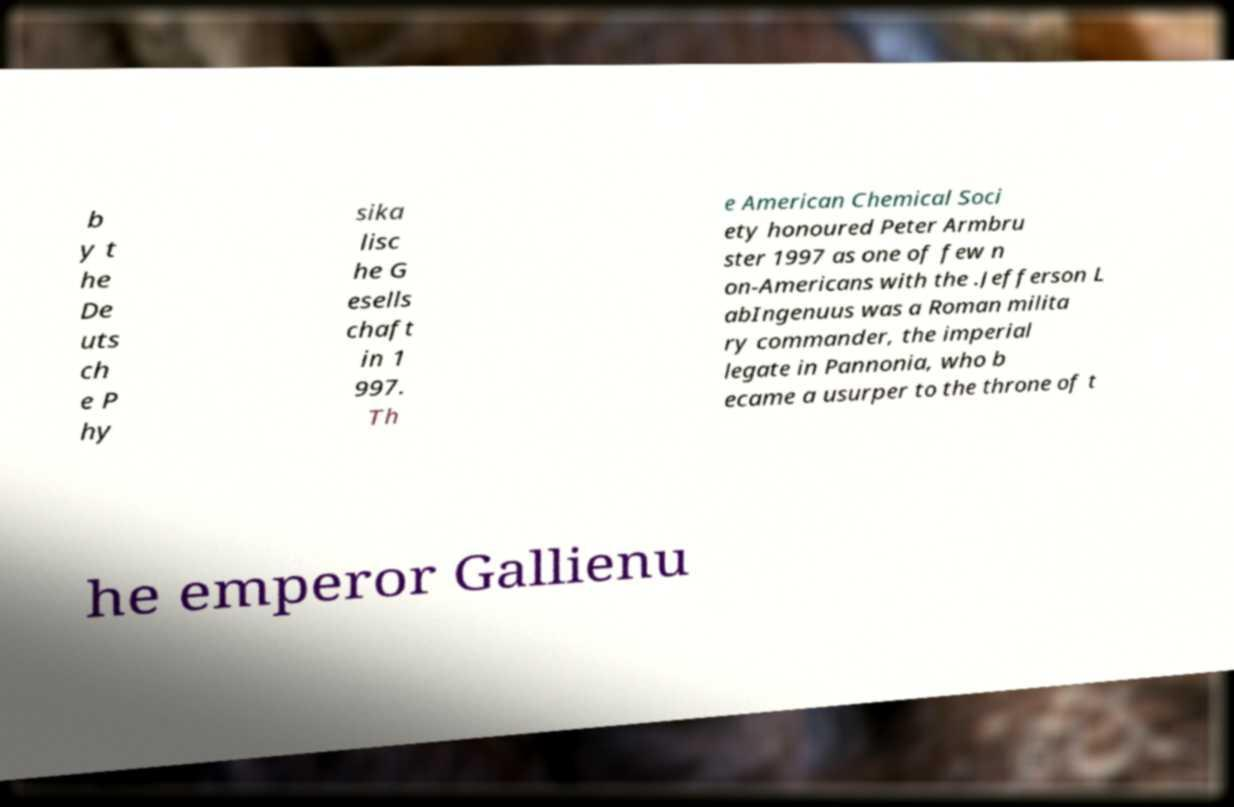Could you extract and type out the text from this image? b y t he De uts ch e P hy sika lisc he G esells chaft in 1 997. Th e American Chemical Soci ety honoured Peter Armbru ster 1997 as one of few n on-Americans with the .Jefferson L abIngenuus was a Roman milita ry commander, the imperial legate in Pannonia, who b ecame a usurper to the throne of t he emperor Gallienu 